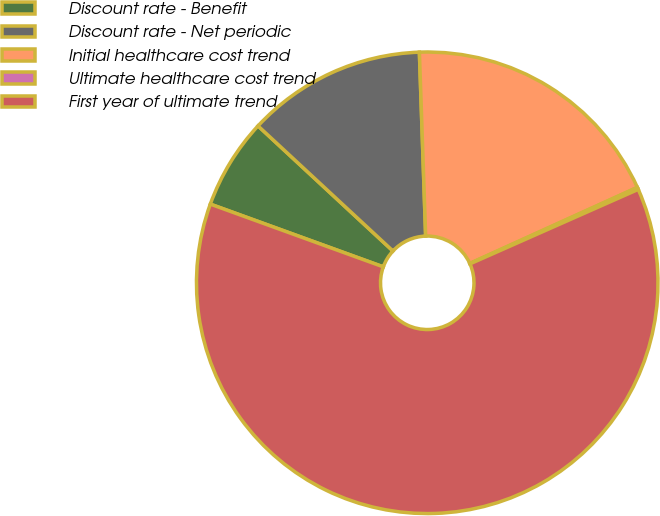<chart> <loc_0><loc_0><loc_500><loc_500><pie_chart><fcel>Discount rate - Benefit<fcel>Discount rate - Net periodic<fcel>Initial healthcare cost trend<fcel>Ultimate healthcare cost trend<fcel>First year of ultimate trend<nl><fcel>6.36%<fcel>12.56%<fcel>18.76%<fcel>0.15%<fcel>62.17%<nl></chart> 